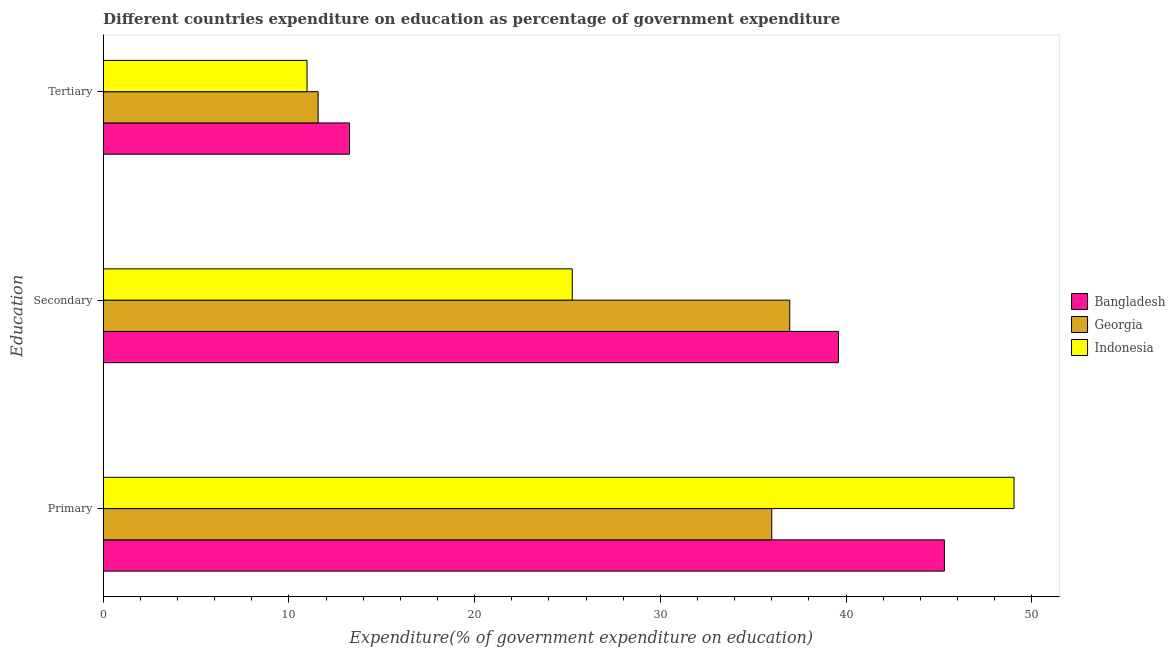How many different coloured bars are there?
Make the answer very short. 3. How many groups of bars are there?
Offer a terse response. 3. Are the number of bars per tick equal to the number of legend labels?
Provide a short and direct response. Yes. How many bars are there on the 2nd tick from the bottom?
Offer a terse response. 3. What is the label of the 2nd group of bars from the top?
Keep it short and to the point. Secondary. What is the expenditure on secondary education in Georgia?
Your answer should be compact. 36.97. Across all countries, what is the maximum expenditure on secondary education?
Make the answer very short. 39.59. Across all countries, what is the minimum expenditure on secondary education?
Offer a terse response. 25.26. In which country was the expenditure on primary education maximum?
Ensure brevity in your answer.  Indonesia. In which country was the expenditure on tertiary education minimum?
Offer a very short reply. Indonesia. What is the total expenditure on tertiary education in the graph?
Offer a very short reply. 35.82. What is the difference between the expenditure on secondary education in Indonesia and that in Georgia?
Your answer should be compact. -11.71. What is the difference between the expenditure on primary education in Georgia and the expenditure on secondary education in Bangladesh?
Ensure brevity in your answer.  -3.59. What is the average expenditure on tertiary education per country?
Ensure brevity in your answer.  11.94. What is the difference between the expenditure on secondary education and expenditure on primary education in Bangladesh?
Provide a short and direct response. -5.7. In how many countries, is the expenditure on tertiary education greater than 44 %?
Keep it short and to the point. 0. What is the ratio of the expenditure on tertiary education in Bangladesh to that in Georgia?
Keep it short and to the point. 1.15. Is the expenditure on tertiary education in Indonesia less than that in Georgia?
Offer a very short reply. Yes. What is the difference between the highest and the second highest expenditure on tertiary education?
Provide a succinct answer. 1.69. What is the difference between the highest and the lowest expenditure on tertiary education?
Keep it short and to the point. 2.29. In how many countries, is the expenditure on tertiary education greater than the average expenditure on tertiary education taken over all countries?
Provide a succinct answer. 1. Is the sum of the expenditure on primary education in Indonesia and Bangladesh greater than the maximum expenditure on secondary education across all countries?
Keep it short and to the point. Yes. What does the 2nd bar from the bottom in Tertiary represents?
Your answer should be compact. Georgia. Are all the bars in the graph horizontal?
Give a very brief answer. Yes. What is the difference between two consecutive major ticks on the X-axis?
Offer a very short reply. 10. How are the legend labels stacked?
Give a very brief answer. Vertical. What is the title of the graph?
Ensure brevity in your answer.  Different countries expenditure on education as percentage of government expenditure. What is the label or title of the X-axis?
Keep it short and to the point. Expenditure(% of government expenditure on education). What is the label or title of the Y-axis?
Ensure brevity in your answer.  Education. What is the Expenditure(% of government expenditure on education) of Bangladesh in Primary?
Your answer should be compact. 45.29. What is the Expenditure(% of government expenditure on education) of Georgia in Primary?
Offer a very short reply. 36. What is the Expenditure(% of government expenditure on education) of Indonesia in Primary?
Ensure brevity in your answer.  49.04. What is the Expenditure(% of government expenditure on education) of Bangladesh in Secondary?
Ensure brevity in your answer.  39.59. What is the Expenditure(% of government expenditure on education) of Georgia in Secondary?
Your answer should be very brief. 36.97. What is the Expenditure(% of government expenditure on education) in Indonesia in Secondary?
Offer a very short reply. 25.26. What is the Expenditure(% of government expenditure on education) of Bangladesh in Tertiary?
Your response must be concise. 13.26. What is the Expenditure(% of government expenditure on education) in Georgia in Tertiary?
Give a very brief answer. 11.58. What is the Expenditure(% of government expenditure on education) in Indonesia in Tertiary?
Provide a succinct answer. 10.98. Across all Education, what is the maximum Expenditure(% of government expenditure on education) of Bangladesh?
Your response must be concise. 45.29. Across all Education, what is the maximum Expenditure(% of government expenditure on education) of Georgia?
Your answer should be very brief. 36.97. Across all Education, what is the maximum Expenditure(% of government expenditure on education) of Indonesia?
Ensure brevity in your answer.  49.04. Across all Education, what is the minimum Expenditure(% of government expenditure on education) in Bangladesh?
Your answer should be compact. 13.26. Across all Education, what is the minimum Expenditure(% of government expenditure on education) of Georgia?
Offer a very short reply. 11.58. Across all Education, what is the minimum Expenditure(% of government expenditure on education) of Indonesia?
Offer a very short reply. 10.98. What is the total Expenditure(% of government expenditure on education) in Bangladesh in the graph?
Offer a terse response. 98.15. What is the total Expenditure(% of government expenditure on education) in Georgia in the graph?
Make the answer very short. 84.55. What is the total Expenditure(% of government expenditure on education) in Indonesia in the graph?
Provide a succinct answer. 85.28. What is the difference between the Expenditure(% of government expenditure on education) in Bangladesh in Primary and that in Secondary?
Provide a succinct answer. 5.7. What is the difference between the Expenditure(% of government expenditure on education) of Georgia in Primary and that in Secondary?
Keep it short and to the point. -0.97. What is the difference between the Expenditure(% of government expenditure on education) of Indonesia in Primary and that in Secondary?
Offer a very short reply. 23.78. What is the difference between the Expenditure(% of government expenditure on education) of Bangladesh in Primary and that in Tertiary?
Make the answer very short. 32.03. What is the difference between the Expenditure(% of government expenditure on education) in Georgia in Primary and that in Tertiary?
Give a very brief answer. 24.42. What is the difference between the Expenditure(% of government expenditure on education) in Indonesia in Primary and that in Tertiary?
Your response must be concise. 38.06. What is the difference between the Expenditure(% of government expenditure on education) of Bangladesh in Secondary and that in Tertiary?
Your answer should be very brief. 26.33. What is the difference between the Expenditure(% of government expenditure on education) of Georgia in Secondary and that in Tertiary?
Provide a succinct answer. 25.39. What is the difference between the Expenditure(% of government expenditure on education) in Indonesia in Secondary and that in Tertiary?
Keep it short and to the point. 14.28. What is the difference between the Expenditure(% of government expenditure on education) in Bangladesh in Primary and the Expenditure(% of government expenditure on education) in Georgia in Secondary?
Offer a terse response. 8.33. What is the difference between the Expenditure(% of government expenditure on education) of Bangladesh in Primary and the Expenditure(% of government expenditure on education) of Indonesia in Secondary?
Ensure brevity in your answer.  20.04. What is the difference between the Expenditure(% of government expenditure on education) in Georgia in Primary and the Expenditure(% of government expenditure on education) in Indonesia in Secondary?
Your answer should be very brief. 10.74. What is the difference between the Expenditure(% of government expenditure on education) in Bangladesh in Primary and the Expenditure(% of government expenditure on education) in Georgia in Tertiary?
Offer a very short reply. 33.72. What is the difference between the Expenditure(% of government expenditure on education) of Bangladesh in Primary and the Expenditure(% of government expenditure on education) of Indonesia in Tertiary?
Provide a succinct answer. 34.32. What is the difference between the Expenditure(% of government expenditure on education) in Georgia in Primary and the Expenditure(% of government expenditure on education) in Indonesia in Tertiary?
Offer a terse response. 25.02. What is the difference between the Expenditure(% of government expenditure on education) in Bangladesh in Secondary and the Expenditure(% of government expenditure on education) in Georgia in Tertiary?
Offer a very short reply. 28.02. What is the difference between the Expenditure(% of government expenditure on education) in Bangladesh in Secondary and the Expenditure(% of government expenditure on education) in Indonesia in Tertiary?
Keep it short and to the point. 28.61. What is the difference between the Expenditure(% of government expenditure on education) of Georgia in Secondary and the Expenditure(% of government expenditure on education) of Indonesia in Tertiary?
Offer a terse response. 25.99. What is the average Expenditure(% of government expenditure on education) in Bangladesh per Education?
Keep it short and to the point. 32.72. What is the average Expenditure(% of government expenditure on education) of Georgia per Education?
Offer a terse response. 28.18. What is the average Expenditure(% of government expenditure on education) in Indonesia per Education?
Give a very brief answer. 28.43. What is the difference between the Expenditure(% of government expenditure on education) in Bangladesh and Expenditure(% of government expenditure on education) in Georgia in Primary?
Your answer should be compact. 9.29. What is the difference between the Expenditure(% of government expenditure on education) of Bangladesh and Expenditure(% of government expenditure on education) of Indonesia in Primary?
Provide a short and direct response. -3.75. What is the difference between the Expenditure(% of government expenditure on education) in Georgia and Expenditure(% of government expenditure on education) in Indonesia in Primary?
Give a very brief answer. -13.04. What is the difference between the Expenditure(% of government expenditure on education) of Bangladesh and Expenditure(% of government expenditure on education) of Georgia in Secondary?
Your response must be concise. 2.62. What is the difference between the Expenditure(% of government expenditure on education) in Bangladesh and Expenditure(% of government expenditure on education) in Indonesia in Secondary?
Your answer should be very brief. 14.33. What is the difference between the Expenditure(% of government expenditure on education) of Georgia and Expenditure(% of government expenditure on education) of Indonesia in Secondary?
Ensure brevity in your answer.  11.71. What is the difference between the Expenditure(% of government expenditure on education) in Bangladesh and Expenditure(% of government expenditure on education) in Georgia in Tertiary?
Provide a succinct answer. 1.69. What is the difference between the Expenditure(% of government expenditure on education) in Bangladesh and Expenditure(% of government expenditure on education) in Indonesia in Tertiary?
Give a very brief answer. 2.29. What is the difference between the Expenditure(% of government expenditure on education) of Georgia and Expenditure(% of government expenditure on education) of Indonesia in Tertiary?
Your response must be concise. 0.6. What is the ratio of the Expenditure(% of government expenditure on education) in Bangladesh in Primary to that in Secondary?
Make the answer very short. 1.14. What is the ratio of the Expenditure(% of government expenditure on education) in Georgia in Primary to that in Secondary?
Provide a short and direct response. 0.97. What is the ratio of the Expenditure(% of government expenditure on education) in Indonesia in Primary to that in Secondary?
Provide a short and direct response. 1.94. What is the ratio of the Expenditure(% of government expenditure on education) in Bangladesh in Primary to that in Tertiary?
Offer a terse response. 3.41. What is the ratio of the Expenditure(% of government expenditure on education) of Georgia in Primary to that in Tertiary?
Keep it short and to the point. 3.11. What is the ratio of the Expenditure(% of government expenditure on education) in Indonesia in Primary to that in Tertiary?
Offer a very short reply. 4.47. What is the ratio of the Expenditure(% of government expenditure on education) of Bangladesh in Secondary to that in Tertiary?
Keep it short and to the point. 2.98. What is the ratio of the Expenditure(% of government expenditure on education) of Georgia in Secondary to that in Tertiary?
Make the answer very short. 3.19. What is the ratio of the Expenditure(% of government expenditure on education) of Indonesia in Secondary to that in Tertiary?
Provide a short and direct response. 2.3. What is the difference between the highest and the second highest Expenditure(% of government expenditure on education) of Bangladesh?
Offer a terse response. 5.7. What is the difference between the highest and the second highest Expenditure(% of government expenditure on education) of Georgia?
Offer a very short reply. 0.97. What is the difference between the highest and the second highest Expenditure(% of government expenditure on education) of Indonesia?
Make the answer very short. 23.78. What is the difference between the highest and the lowest Expenditure(% of government expenditure on education) of Bangladesh?
Offer a very short reply. 32.03. What is the difference between the highest and the lowest Expenditure(% of government expenditure on education) in Georgia?
Make the answer very short. 25.39. What is the difference between the highest and the lowest Expenditure(% of government expenditure on education) in Indonesia?
Provide a succinct answer. 38.06. 